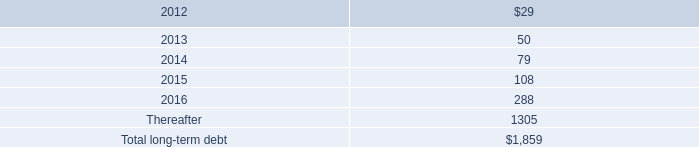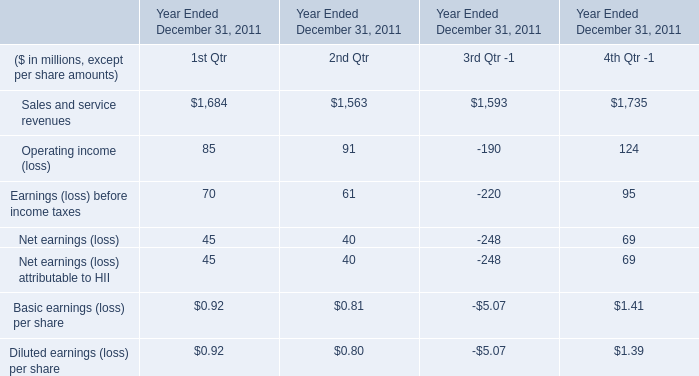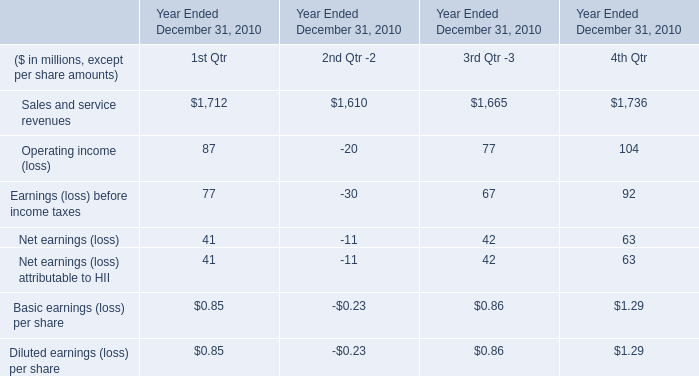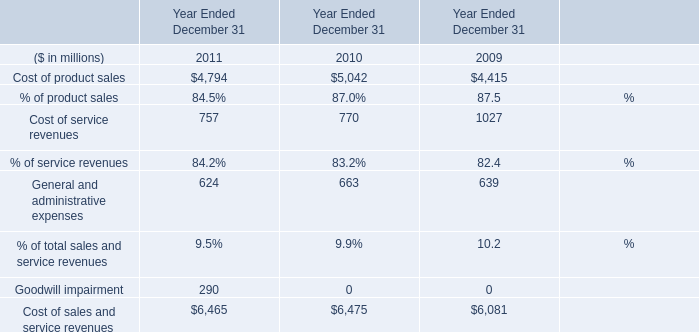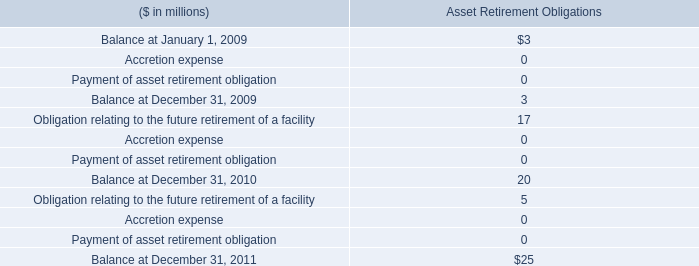What is the proportion of Cost of service revenues to the total in 2011? 
Computations: (757 / 6465)
Answer: 0.11709. 